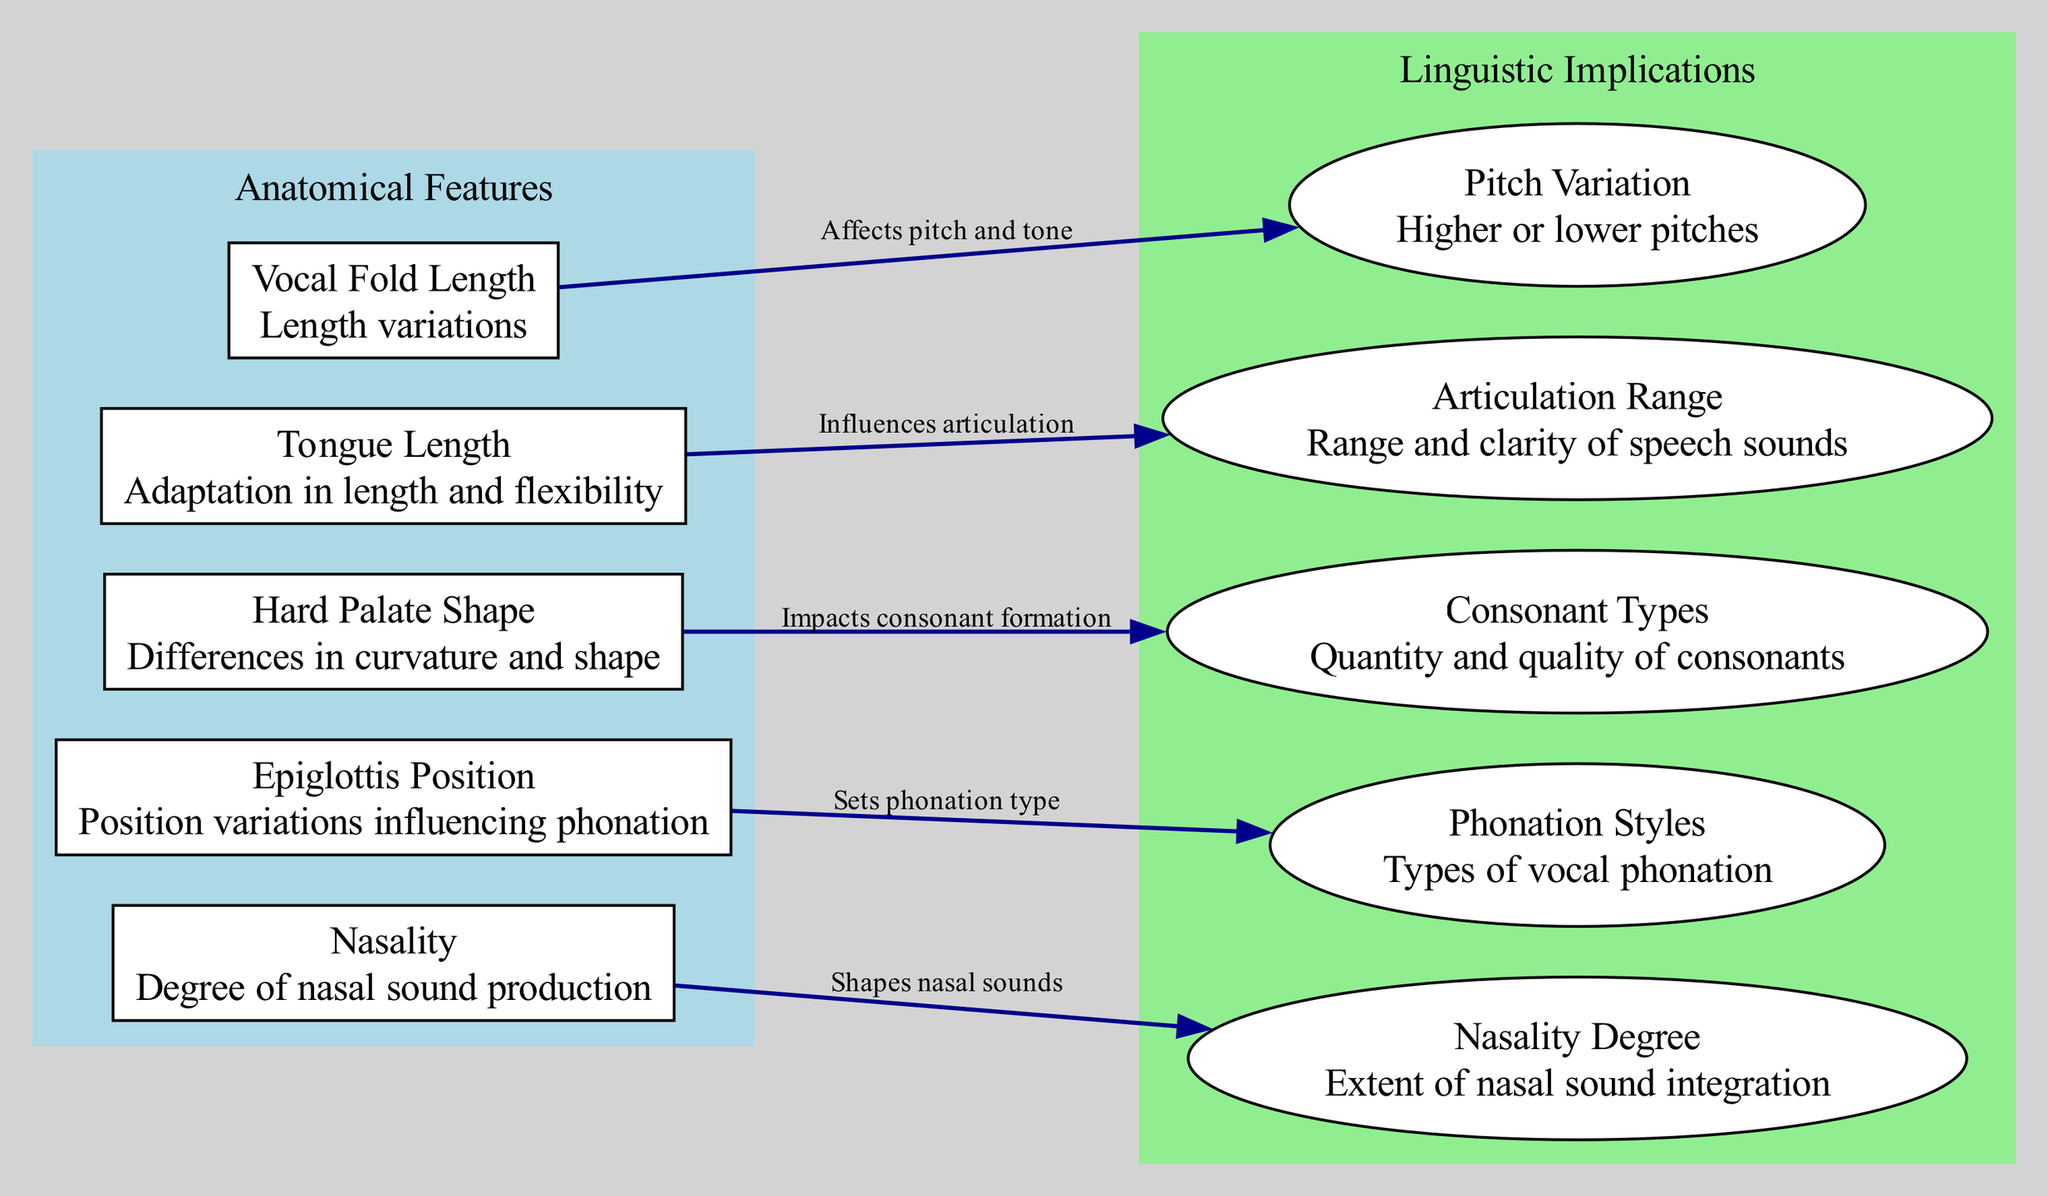What are the nodes representing anatomical features? The nodes representing anatomical features are Vocal Fold Length, Tongue Length, Hard Palate Shape, Epiglottis Position, and Nasality. These are the main components labeled in the diagram specifically under "Anatomical Features."
Answer: Vocal Fold Length, Tongue Length, Hard Palate Shape, Epiglottis Position, Nasality How many linguistic implications are listed? The diagram indicates a total of five linguistic implications, each connected to one of the anatomical features. This is confirmed by counting the distinct linguistic implication nodes shown in the section labeled "Linguistic Implications."
Answer: 5 What impact does the Vocal Fold Length have? The edge connecting Vocal Fold Length to its linguistic implication states that it affects the pitch and tone, specifically suggesting that variations in its length can lead to higher or lower pitches in speech.
Answer: Affects pitch and tone Which anatomical feature influences articulation? Tongue Length influences articulation, as indicated by the directed edge from Tongue Length to its corresponding linguistic implication that specifically states this relationship.
Answer: Tongue Length What is the relationship between Hard Palate Shape and linguistic implications? The Hard Palate Shape node connects to "Linguistic Implication3," which states that it impacts consonant formation. Therefore, changes in this anatomical feature can affect how consonants are produced.
Answer: Impacts consonant formation Explain how Epiglottis Position sets phonation type. The edge from Epiglottis Position to "Linguistic Implication4" explicitly states that it sets phonation type. This means that the placement of the epiglottis influences the kind of sounds a person can produce, affecting vocal characteristics and styles.
Answer: Sets phonation type What does the Nasality node shape? The Nasality node connects to "Linguistic Implication5," which indicates that it shapes the degree of nasal sound production in speech, meaning it affects how nasal or non-nasal sounds are integrated into language.
Answer: Shapes nasal sounds How does the Tongue Length affect speech clarity? The Tongue Length influences articulation range according to its connected linguistic implication. This implies that variations in tongue length adjust the range and clarity of speech sounds that a person can produce effectively.
Answer: Influences articulation 